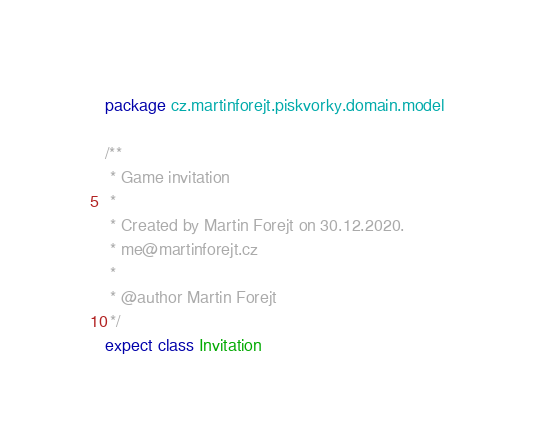<code> <loc_0><loc_0><loc_500><loc_500><_Kotlin_>package cz.martinforejt.piskvorky.domain.model

/**
 * Game invitation
 *
 * Created by Martin Forejt on 30.12.2020.
 * me@martinforejt.cz
 *
 * @author Martin Forejt
 */
expect class Invitation</code> 